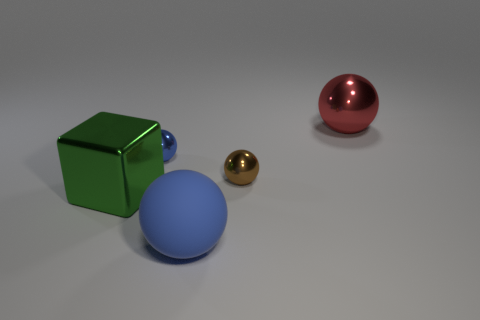Are there an equal number of brown shiny things that are on the left side of the metallic cube and small metal objects on the right side of the large red shiny thing?
Keep it short and to the point. Yes. The other object that is the same color as the rubber object is what shape?
Provide a succinct answer. Sphere. There is another metal sphere that is the same size as the blue shiny ball; what color is it?
Your response must be concise. Brown. How many objects are large balls behind the green block or tiny balls to the left of the tiny brown shiny ball?
Your answer should be compact. 2. Are the green thing and the large object that is behind the green block made of the same material?
Provide a succinct answer. Yes. How many other things are the same shape as the blue metallic object?
Offer a very short reply. 3. There is a large sphere behind the green cube behind the blue object that is in front of the brown shiny object; what is its material?
Provide a short and direct response. Metal. Is the number of big green objects that are to the right of the tiny brown shiny object the same as the number of large brown shiny cylinders?
Provide a succinct answer. Yes. Is the material of the tiny thing on the right side of the big rubber ball the same as the blue ball that is in front of the brown metal ball?
Your response must be concise. No. Is there any other thing that is the same material as the large blue object?
Ensure brevity in your answer.  No. 